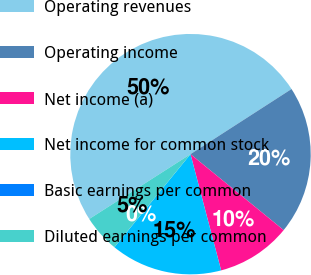Convert chart. <chart><loc_0><loc_0><loc_500><loc_500><pie_chart><fcel>Operating revenues<fcel>Operating income<fcel>Net income (a)<fcel>Net income for common stock<fcel>Basic earnings per common<fcel>Diluted earnings per common<nl><fcel>49.95%<fcel>20.0%<fcel>10.01%<fcel>15.0%<fcel>0.02%<fcel>5.02%<nl></chart> 